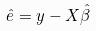Convert formula to latex. <formula><loc_0><loc_0><loc_500><loc_500>\hat { e } = y - X \hat { \beta }</formula> 